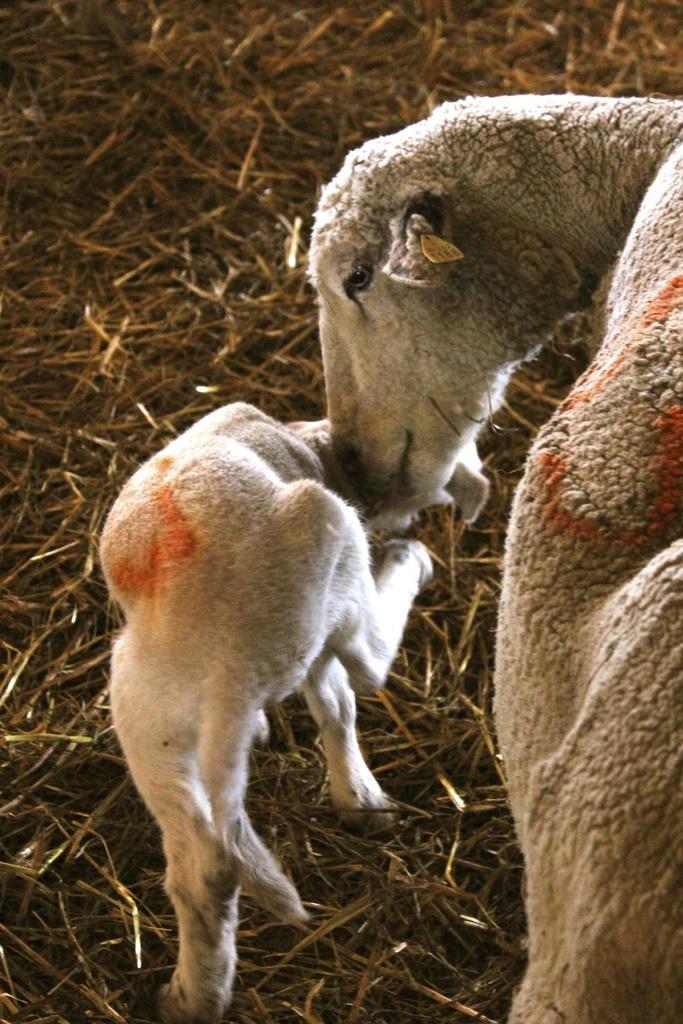Could you give a brief overview of what you see in this image? This is a zoomed in picture. In the foreground we can see a sheep and a lamb standing on the ground and we can see the dry stems are lying on the ground. 